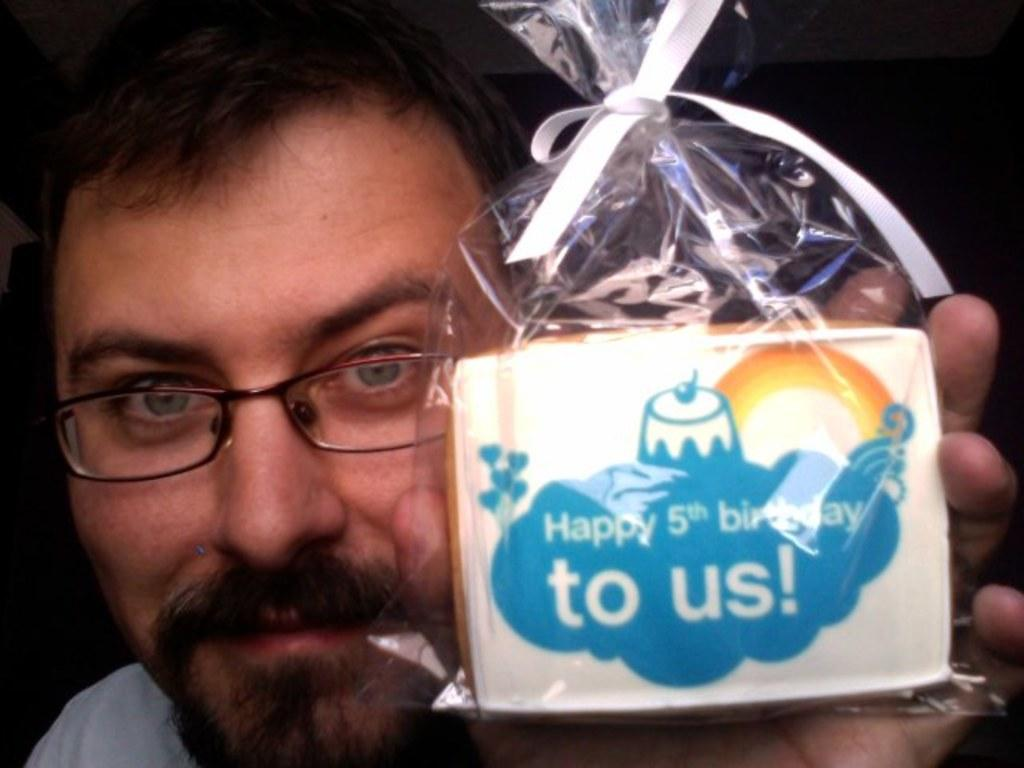Who is present in the image? There is a man in the image. What is the man holding in the image? The man is holding a gift. Can you describe the man's appearance? The man is wearing spectacles. What color is the ribbon visible in the image? There is a white color ribbon visible in the image. What language is the man speaking in the image? The image does not provide any information about the language the man is speaking. 